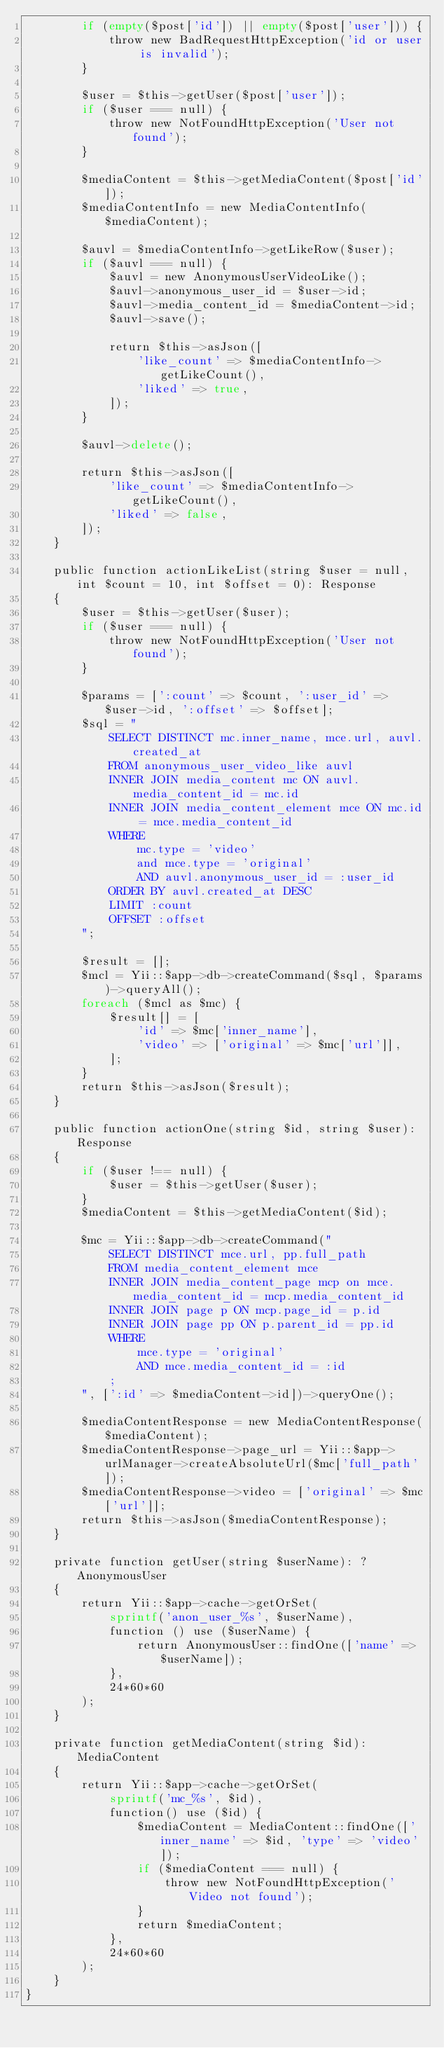<code> <loc_0><loc_0><loc_500><loc_500><_PHP_>        if (empty($post['id']) || empty($post['user'])) {
            throw new BadRequestHttpException('id or user is invalid');
        }

        $user = $this->getUser($post['user']);
        if ($user === null) {
            throw new NotFoundHttpException('User not found');
        }

        $mediaContent = $this->getMediaContent($post['id']);
        $mediaContentInfo = new MediaContentInfo($mediaContent);
        
        $auvl = $mediaContentInfo->getLikeRow($user);
        if ($auvl === null) {
            $auvl = new AnonymousUserVideoLike();
            $auvl->anonymous_user_id = $user->id;
            $auvl->media_content_id = $mediaContent->id;
            $auvl->save();

            return $this->asJson([
                'like_count' => $mediaContentInfo->getLikeCount(),
                'liked' => true,
            ]);
        }

        $auvl->delete();

        return $this->asJson([
            'like_count' => $mediaContentInfo->getLikeCount(),
            'liked' => false,
        ]);
    }

    public function actionLikeList(string $user = null, int $count = 10, int $offset = 0): Response
    {
        $user = $this->getUser($user);
        if ($user === null) {
            throw new NotFoundHttpException('User not found');
        }

        $params = [':count' => $count, ':user_id' => $user->id, ':offset' => $offset];
        $sql = "
            SELECT DISTINCT mc.inner_name, mce.url, auvl.created_at
            FROM anonymous_user_video_like auvl
            INNER JOIN media_content mc ON auvl.media_content_id = mc.id
            INNER JOIN media_content_element mce ON mc.id = mce.media_content_id
            WHERE 
                mc.type = 'video'
                and mce.type = 'original'
                AND auvl.anonymous_user_id = :user_id
            ORDER BY auvl.created_at DESC
            LIMIT :count
            OFFSET :offset
        ";

        $result = [];
        $mcl = Yii::$app->db->createCommand($sql, $params)->queryAll();
        foreach ($mcl as $mc) {
            $result[] = [
                'id' => $mc['inner_name'],
                'video' => ['original' => $mc['url']],
            ];
        }
        return $this->asJson($result);
    }

    public function actionOne(string $id, string $user): Response
    {
        if ($user !== null) {
            $user = $this->getUser($user);
        }
        $mediaContent = $this->getMediaContent($id);

        $mc = Yii::$app->db->createCommand("
            SELECT DISTINCT mce.url, pp.full_path
            FROM media_content_element mce
            INNER JOIN media_content_page mcp on mce.media_content_id = mcp.media_content_id
            INNER JOIN page p ON mcp.page_id = p.id
            INNER JOIN page pp ON p.parent_id = pp.id
            WHERE
                mce.type = 'original'
                AND mce.media_content_id = :id
            ;
        ", [':id' => $mediaContent->id])->queryOne();

        $mediaContentResponse = new MediaContentResponse($mediaContent);
        $mediaContentResponse->page_url = Yii::$app->urlManager->createAbsoluteUrl($mc['full_path']);
        $mediaContentResponse->video = ['original' => $mc['url']];
        return $this->asJson($mediaContentResponse);
    }

    private function getUser(string $userName): ?AnonymousUser
    {
        return Yii::$app->cache->getOrSet(
            sprintf('anon_user_%s', $userName),
            function () use ($userName) {
                return AnonymousUser::findOne(['name' => $userName]);
            },
            24*60*60
        );
    }

    private function getMediaContent(string $id): MediaContent
    {
        return Yii::$app->cache->getOrSet(
            sprintf('mc_%s', $id),
            function() use ($id) {
                $mediaContent = MediaContent::findOne(['inner_name' => $id, 'type' => 'video']);
                if ($mediaContent === null) {
                    throw new NotFoundHttpException('Video not found');
                }
                return $mediaContent;
            },
            24*60*60
        );
    }
}
</code> 